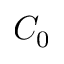<formula> <loc_0><loc_0><loc_500><loc_500>C _ { 0 }</formula> 